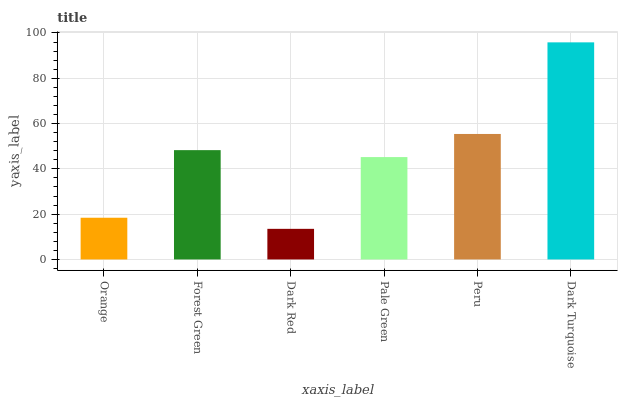Is Dark Red the minimum?
Answer yes or no. Yes. Is Dark Turquoise the maximum?
Answer yes or no. Yes. Is Forest Green the minimum?
Answer yes or no. No. Is Forest Green the maximum?
Answer yes or no. No. Is Forest Green greater than Orange?
Answer yes or no. Yes. Is Orange less than Forest Green?
Answer yes or no. Yes. Is Orange greater than Forest Green?
Answer yes or no. No. Is Forest Green less than Orange?
Answer yes or no. No. Is Forest Green the high median?
Answer yes or no. Yes. Is Pale Green the low median?
Answer yes or no. Yes. Is Dark Red the high median?
Answer yes or no. No. Is Orange the low median?
Answer yes or no. No. 